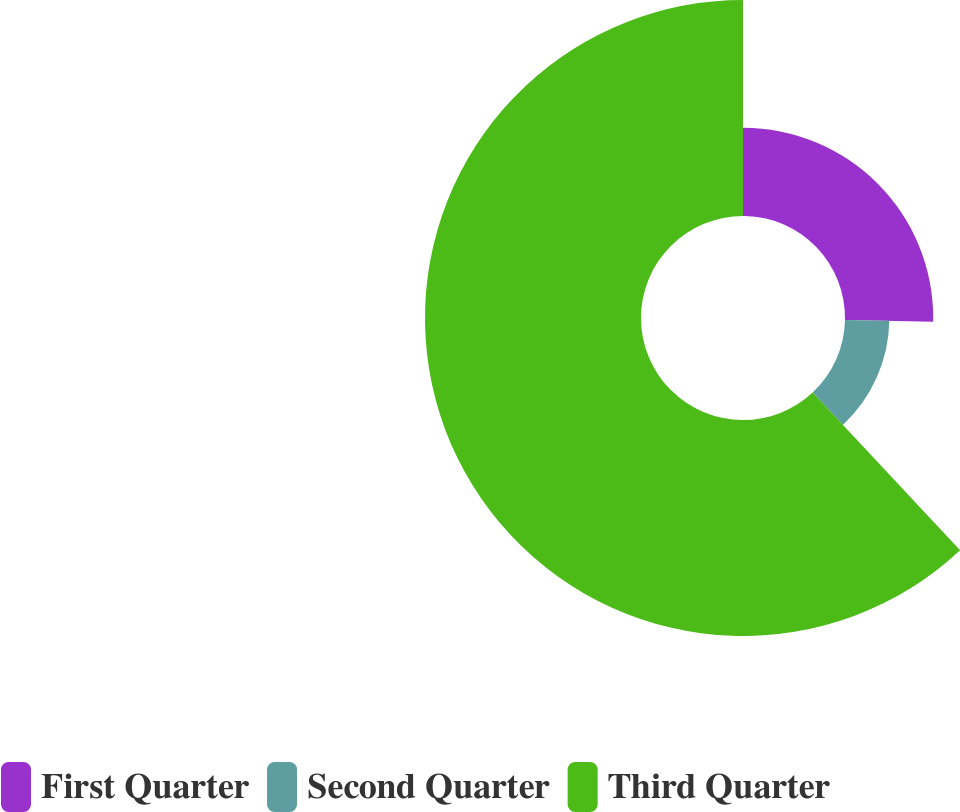Convert chart to OTSL. <chart><loc_0><loc_0><loc_500><loc_500><pie_chart><fcel>First Quarter<fcel>Second Quarter<fcel>Third Quarter<nl><fcel>25.31%<fcel>12.73%<fcel>61.96%<nl></chart> 